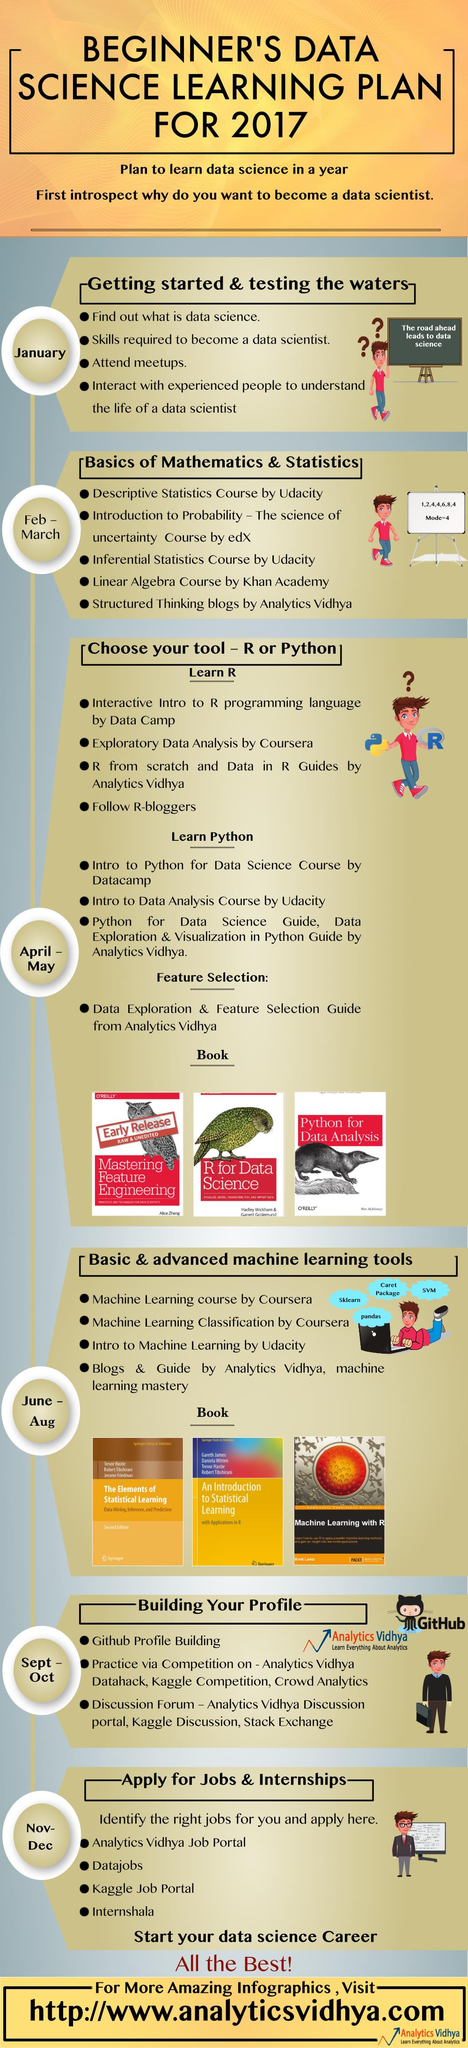Specify some key components in this picture. The use of programming languages such as R and Python is prevalent in the field of Data Science. In the month of September to October, the step of the beginner's data science learning plan that should be taken is building your profile. Udacity offers two courses in Statistics. It is known that the publisher of data science books is O'Reilly. 